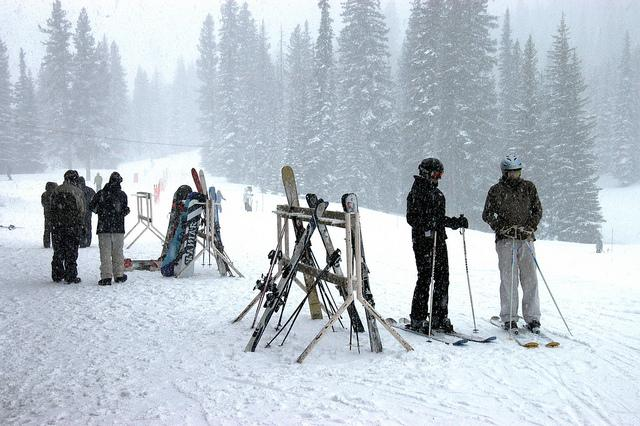What could potentially impede their vision shortly? snow 